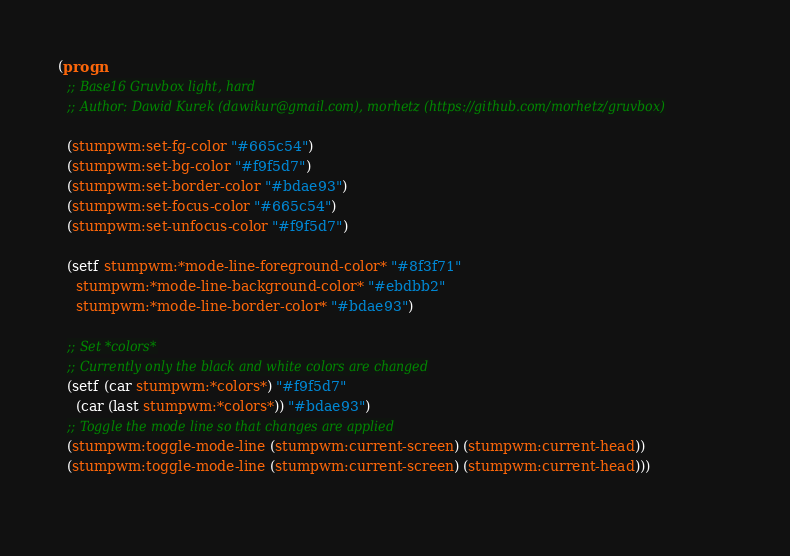Convert code to text. <code><loc_0><loc_0><loc_500><loc_500><_Lisp_>(progn
  ;; Base16 Gruvbox light, hard
  ;; Author: Dawid Kurek (dawikur@gmail.com), morhetz (https://github.com/morhetz/gruvbox)

  (stumpwm:set-fg-color "#665c54")
  (stumpwm:set-bg-color "#f9f5d7")
  (stumpwm:set-border-color "#bdae93")
  (stumpwm:set-focus-color "#665c54")
  (stumpwm:set-unfocus-color "#f9f5d7")

  (setf stumpwm:*mode-line-foreground-color* "#8f3f71"
	stumpwm:*mode-line-background-color* "#ebdbb2"
	stumpwm:*mode-line-border-color* "#bdae93")

  ;; Set *colors*
  ;; Currently only the black and white colors are changed
  (setf (car stumpwm:*colors*) "#f9f5d7"
	(car (last stumpwm:*colors*)) "#bdae93")
  ;; Toggle the mode line so that changes are applied
  (stumpwm:toggle-mode-line (stumpwm:current-screen) (stumpwm:current-head))
  (stumpwm:toggle-mode-line (stumpwm:current-screen) (stumpwm:current-head)))
       
</code> 